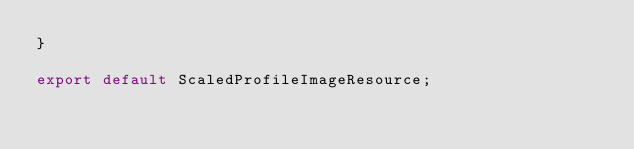Convert code to text. <code><loc_0><loc_0><loc_500><loc_500><_TypeScript_>}

export default ScaledProfileImageResource;
</code> 